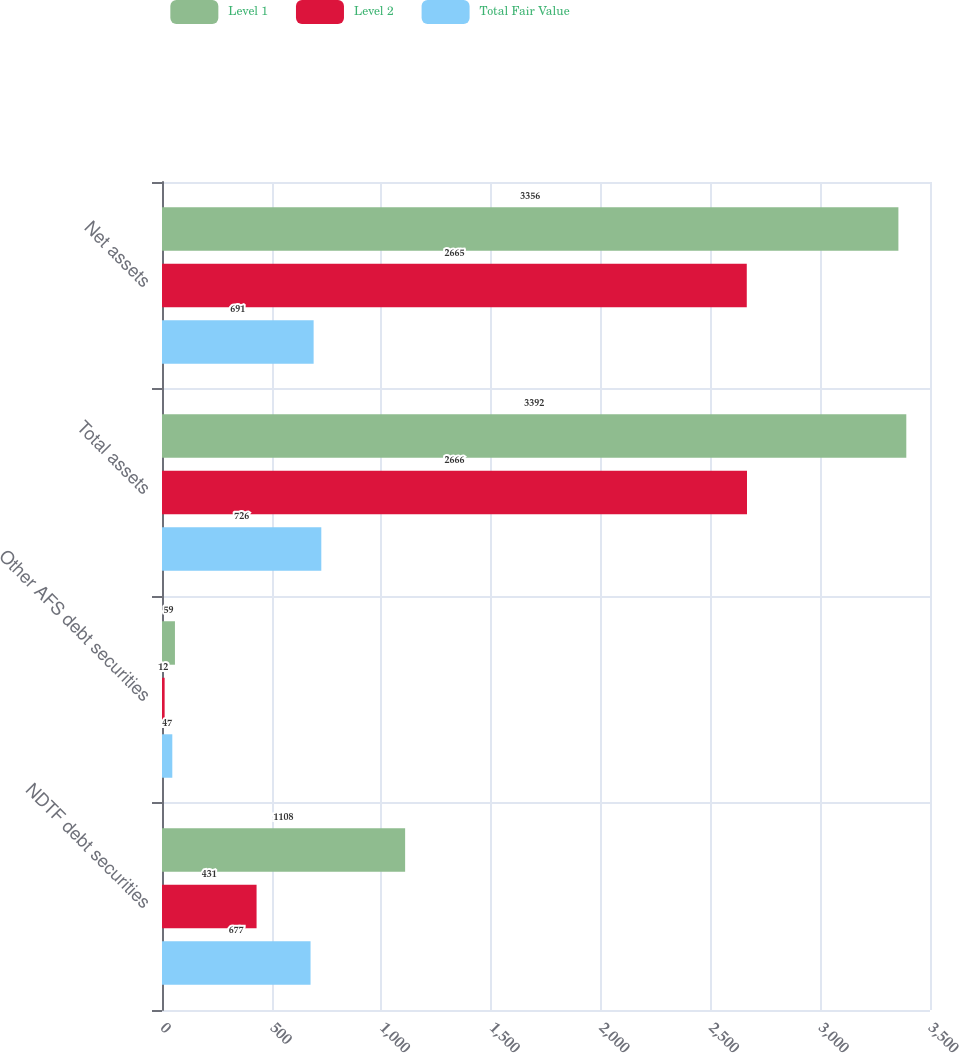Convert chart. <chart><loc_0><loc_0><loc_500><loc_500><stacked_bar_chart><ecel><fcel>NDTF debt securities<fcel>Other AFS debt securities<fcel>Total assets<fcel>Net assets<nl><fcel>Level 1<fcel>1108<fcel>59<fcel>3392<fcel>3356<nl><fcel>Level 2<fcel>431<fcel>12<fcel>2666<fcel>2665<nl><fcel>Total Fair Value<fcel>677<fcel>47<fcel>726<fcel>691<nl></chart> 